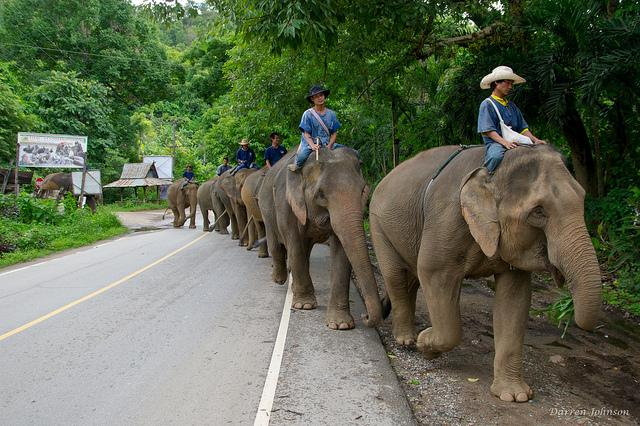What is on top of the elephants?

Choices:
A) bows
B) ladders
C) statues
D) people people 